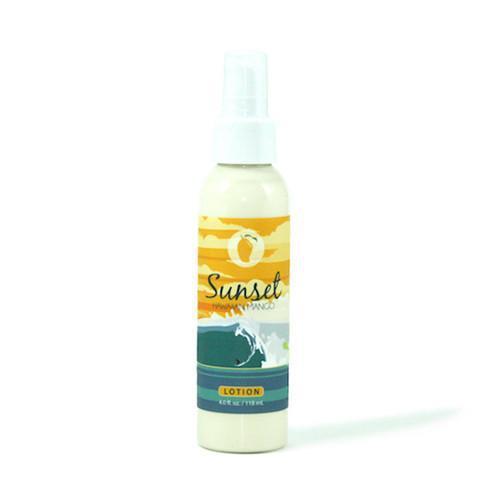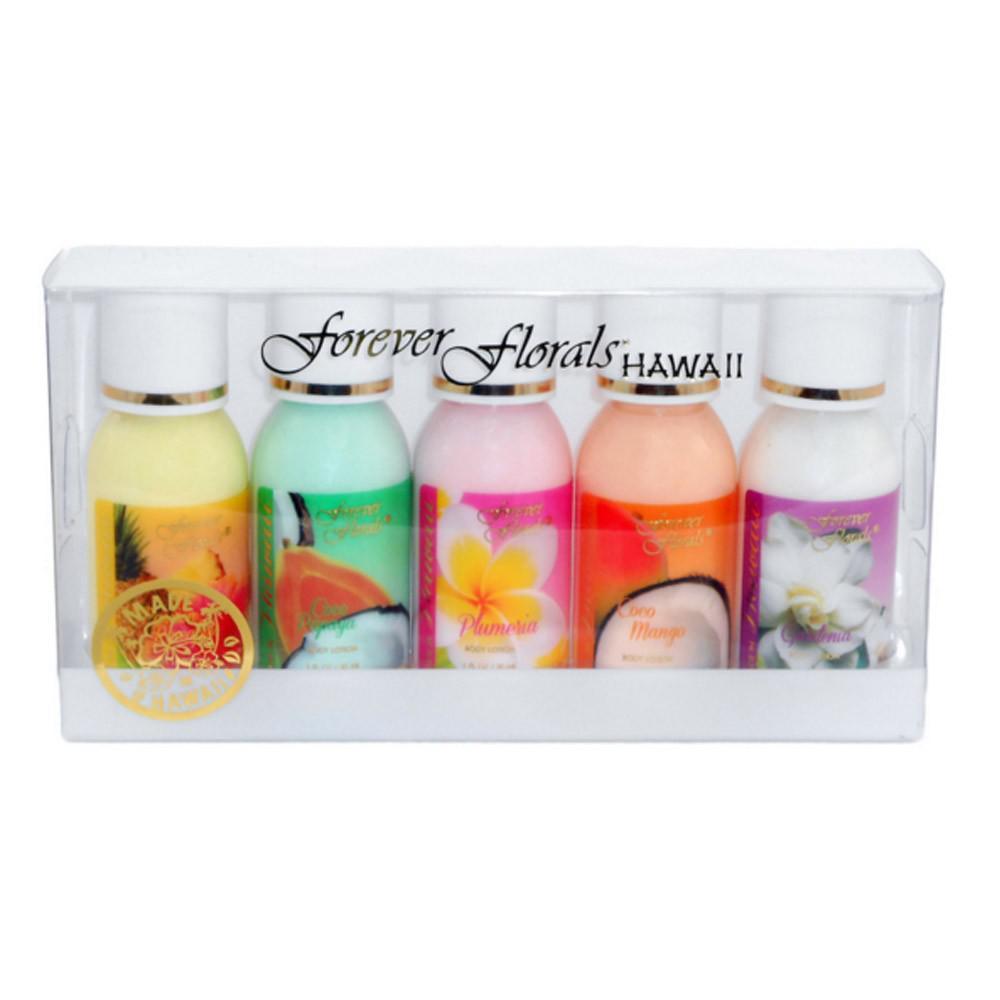The first image is the image on the left, the second image is the image on the right. For the images shown, is this caption "An image shows one tube-type skincare product standing upright on its green cap." true? Answer yes or no. No. The first image is the image on the left, the second image is the image on the right. Examine the images to the left and right. Is the description "There is a single bottle in one of the images, and in the other image there are more than three other bottles." accurate? Answer yes or no. Yes. 